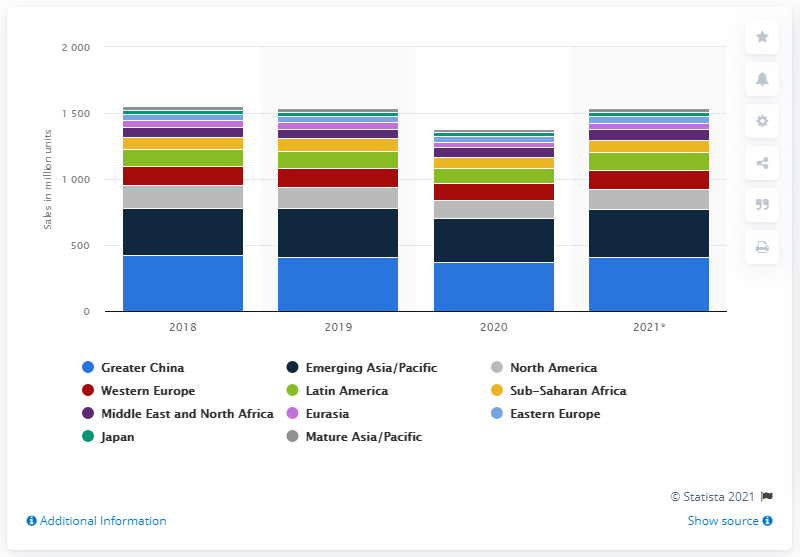Outline some significant characteristics in this image. In 2020, a total of 365.89 million smartphones were sold in Greater China. 